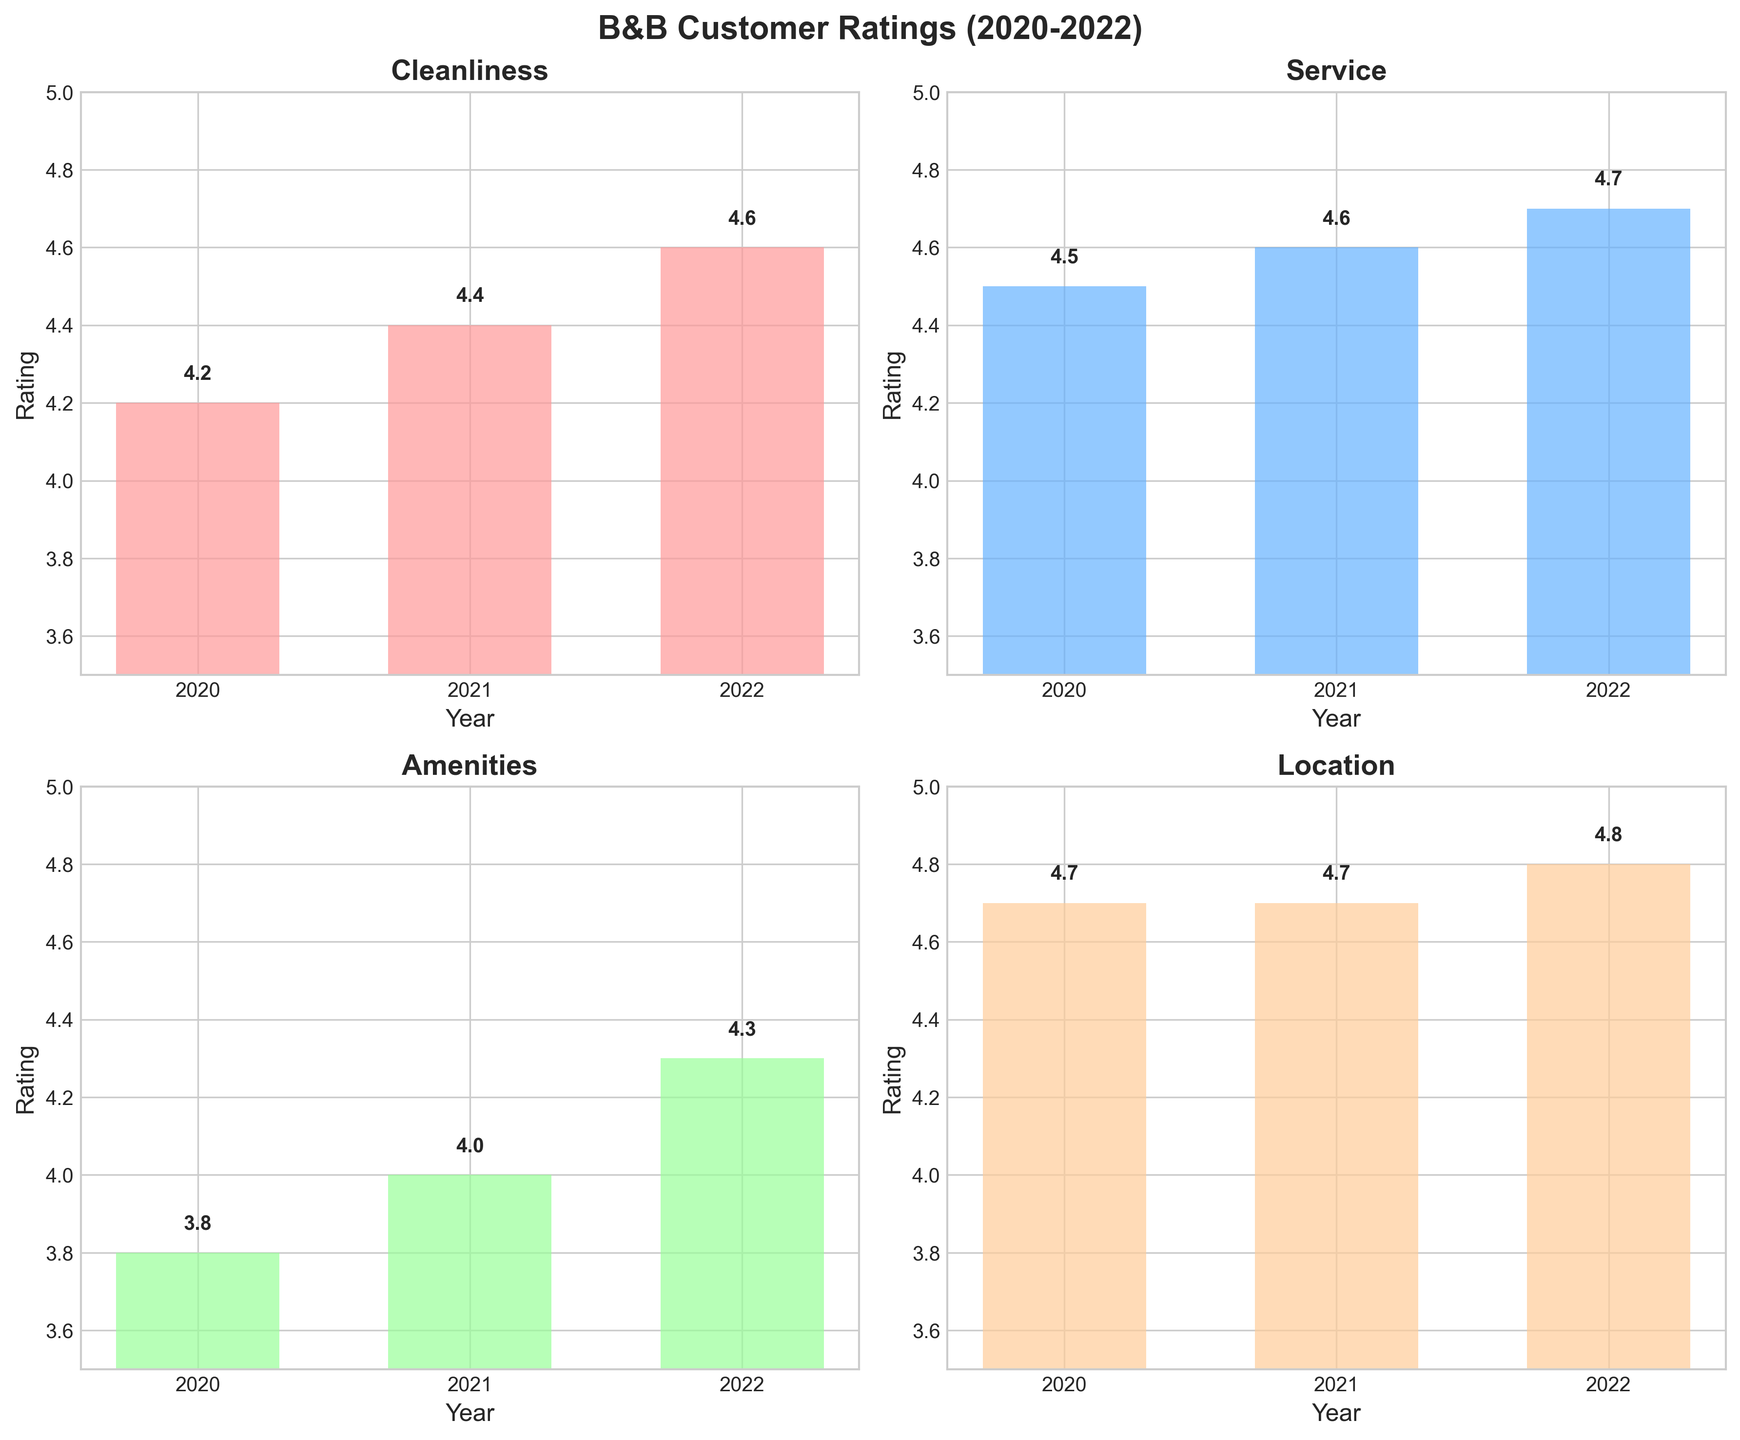What is the average rating for Cleanliness over the past 3 years? First, find the ratings for Cleanliness for each year (4.2, 4.4, 4.6). Add the ratings together: 4.2 + 4.4 + 4.6 = 13.2. Then, divide by the number of years (3): 13.2 / 3 = 4.4
Answer: 4.4 Which aspect received the highest rating in 2022? Look at the y-axis values for the bar representing each aspect in 2022. Cleanliness is 4.6, Service is 4.7, Amenities is 4.3, and Location is 4.8. The highest value is 4.8 for Location
Answer: Location How did the rating for Amenities change from 2020 to 2021? The rating for Amenities in 2020 is 3.8 and in 2021 is 4.0. Subtract the 2020 rating from the 2021 rating: 4.0 - 3.8 = 0.2. The rating increased by 0.2
Answer: Increased by 0.2 Which year had the highest overall average rating across all aspects? Calculate the average rating for each year by summing the ratings and dividing by 4 (number of aspects). For 2020: (4.2 + 4.5 + 3.8 + 4.7) / 4 = 4.3. For 2021: (4.4 + 4.6 + 4.0 + 4.7) / 4 = 4.425. For 2022: (4.6 + 4.7 + 4.3 + 4.8) / 4 = 4.6. The highest average rating is in 2022
Answer: 2022 Was service rating higher or lower than cleanliness rating in 2021? Compare the bar heights for Service and Cleanliness in 2021. The rating for Service in 2021 is 4.6 and for Cleanliness is 4.4. Service has a higher rating than Cleanliness
Answer: Higher How much did the Location rating increase from 2021 to 2022? The Location rating in 2021 is 4.7 and in 2022 is 4.8. Subtract the 2021 rating from the 2022 rating: 4.8 - 4.7 = 0.1
Answer: 0.1 Which aspect had the most consistent rating across the 3 years? Look at the variability in the bar heights for each aspect. Cleanliness ranges from 4.2 to 4.6 (range 0.4), Service ranges from 4.5 to 4.7 (range 0.2), Amenities ranges from 3.8 to 4.3 (range 0.5), and Location ranges from 4.7 to 4.8 (range 0.1). Location has the smallest range and is thus the most consistent
Answer: Location 